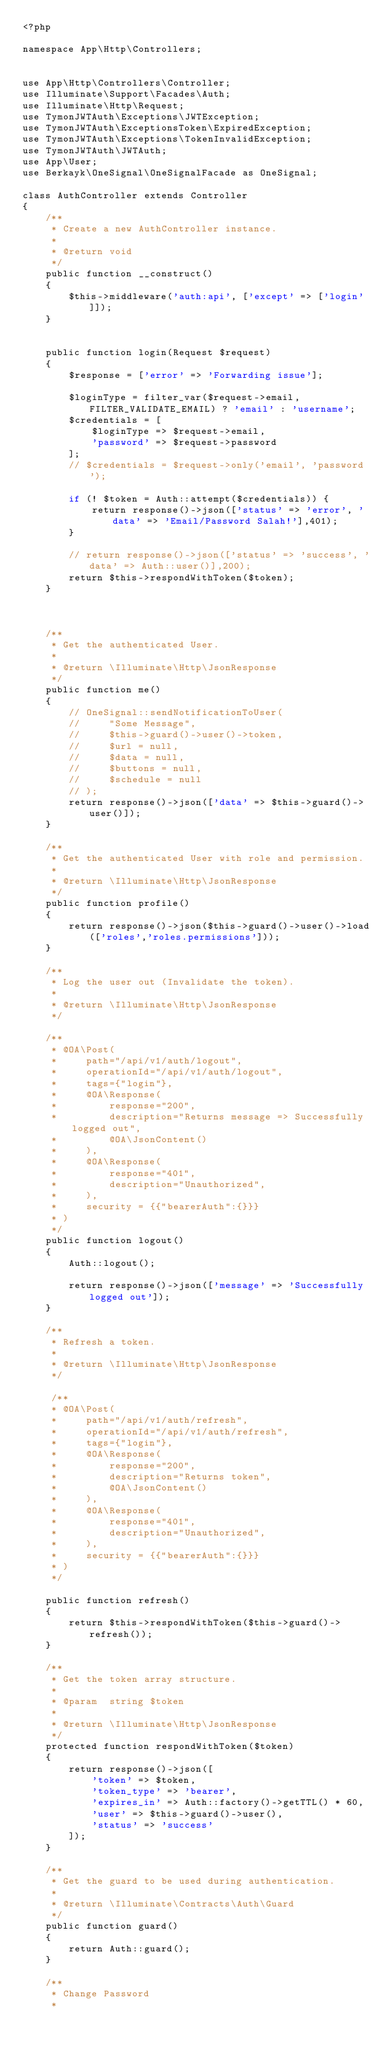<code> <loc_0><loc_0><loc_500><loc_500><_PHP_><?php

namespace App\Http\Controllers;


use App\Http\Controllers\Controller;
use Illuminate\Support\Facades\Auth;
use Illuminate\Http\Request;
use TymonJWTAuth\Exceptions\JWTException;
use TymonJWTAuth\ExceptionsToken\ExpiredException;
use TymonJWTAuth\Exceptions\TokenInvalidException;
use TymonJWTAuth\JWTAuth;
use App\User;
use Berkayk\OneSignal\OneSignalFacade as OneSignal;

class AuthController extends Controller
{
    /**
     * Create a new AuthController instance.
     *
     * @return void
     */
    public function __construct()
    {
        $this->middleware('auth:api', ['except' => ['login']]);
    }

    
    public function login(Request $request)
    {
        $response = ['error' => 'Forwarding issue'];

        $loginType = filter_var($request->email, FILTER_VALIDATE_EMAIL) ? 'email' : 'username';
        $credentials = [
            $loginType => $request->email,
            'password' => $request->password
        ];
        // $credentials = $request->only('email', 'password');
        
        if (! $token = Auth::attempt($credentials)) {
            return response()->json(['status' => 'error', 'data' => 'Email/Password Salah!'],401);
        }

        // return response()->json(['status' => 'success', 'data' => Auth::user()],200);
        return $this->respondWithToken($token);
    }
    


    /**
     * Get the authenticated User.
     *
     * @return \Illuminate\Http\JsonResponse
     */
    public function me()
    {
        // OneSignal::sendNotificationToUser(
        //     "Some Message", 
        //     $this->guard()->user()->token,
        //     $url = null, 
        //     $data = null, 
        //     $buttons = null, 
        //     $schedule = null
        // );
        return response()->json(['data' => $this->guard()->user()]);
    }

    /**
     * Get the authenticated User with role and permission.
     *
     * @return \Illuminate\Http\JsonResponse
     */
    public function profile()
    {
        return response()->json($this->guard()->user()->load(['roles','roles.permissions']));
    }

    /**
     * Log the user out (Invalidate the token).
     *
     * @return \Illuminate\Http\JsonResponse
     */

    /**
     * @OA\Post(
     *     path="/api/v1/auth/logout",
     *     operationId="/api/v1/auth/logout",
     *     tags={"login"},
     *     @OA\Response(
     *         response="200",
     *         description="Returns message => Successfully logged out",
     *         @OA\JsonContent()
     *     ),
     *     @OA\Response(
     *         response="401",
     *         description="Unauthorized",
     *     ),
     *     security = {{"bearerAuth":{}}}
     * )
     */
    public function logout()
    {
        Auth::logout();

        return response()->json(['message' => 'Successfully logged out']);
    }

    /**
     * Refresh a token.
     *
     * @return \Illuminate\Http\JsonResponse
     */

     /**
     * @OA\Post(
     *     path="/api/v1/auth/refresh",
     *     operationId="/api/v1/auth/refresh",
     *     tags={"login"},
     *     @OA\Response(
     *         response="200",
     *         description="Returns token",
     *         @OA\JsonContent()
     *     ),
     *     @OA\Response(
     *         response="401",
     *         description="Unauthorized",
     *     ),
     *     security = {{"bearerAuth":{}}}
     * )
     */

    public function refresh()
    {
        return $this->respondWithToken($this->guard()->refresh());
    }

    /**
     * Get the token array structure.
     *
     * @param  string $token
     *
     * @return \Illuminate\Http\JsonResponse
     */
    protected function respondWithToken($token)
    {
        return response()->json([
            'token' => $token,
            'token_type' => 'bearer',
            'expires_in' => Auth::factory()->getTTL() * 60,
            'user' => $this->guard()->user(),
            'status' => 'success'
        ]);
    }

    /**
     * Get the guard to be used during authentication.
     *
     * @return \Illuminate\Contracts\Auth\Guard
     */
    public function guard()
    {
        return Auth::guard();
    }

    /**
     * Change Password
     *</code> 